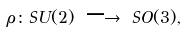<formula> <loc_0><loc_0><loc_500><loc_500>\rho \colon S U ( 2 ) \ { \longrightarrow } \ S O ( 3 ) ,</formula> 